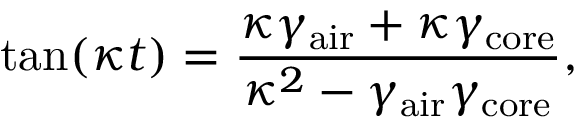Convert formula to latex. <formula><loc_0><loc_0><loc_500><loc_500>t a n ( \kappa t ) = \frac { \kappa \gamma _ { a i r } + \kappa \gamma _ { c o r e } } { \kappa ^ { 2 } - \gamma _ { a i r } \gamma _ { c o r e } } ,</formula> 